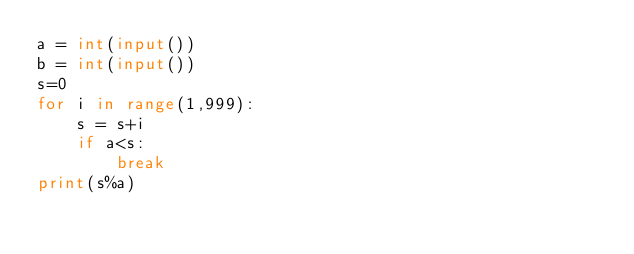<code> <loc_0><loc_0><loc_500><loc_500><_Python_>a = int(input())
b = int(input())
s=0
for i in range(1,999):
    s = s+i
    if a<s:
        break
print(s%a)</code> 